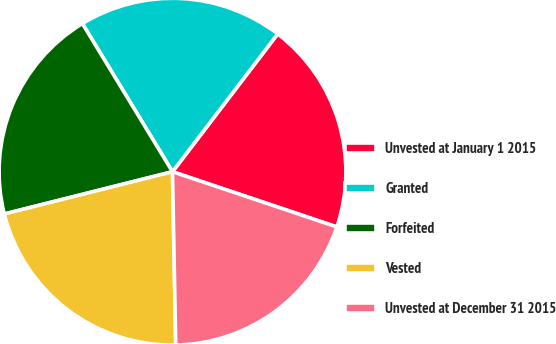Convert chart to OTSL. <chart><loc_0><loc_0><loc_500><loc_500><pie_chart><fcel>Unvested at January 1 2015<fcel>Granted<fcel>Forfeited<fcel>Vested<fcel>Unvested at December 31 2015<nl><fcel>19.78%<fcel>19.07%<fcel>20.22%<fcel>21.38%<fcel>19.54%<nl></chart> 